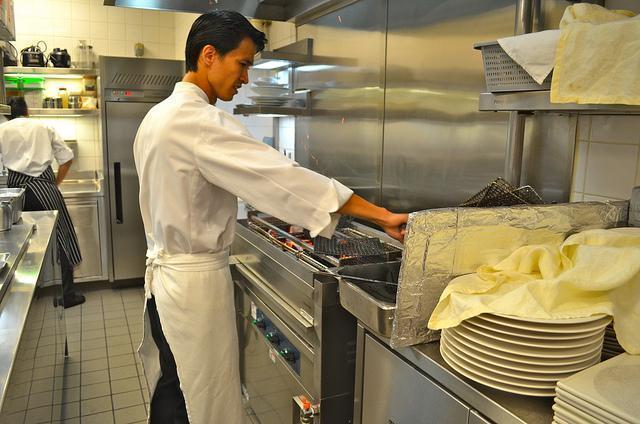How many people can you see?
Give a very brief answer. 2. How many cars on the locomotive have unprotected wheels?
Give a very brief answer. 0. 